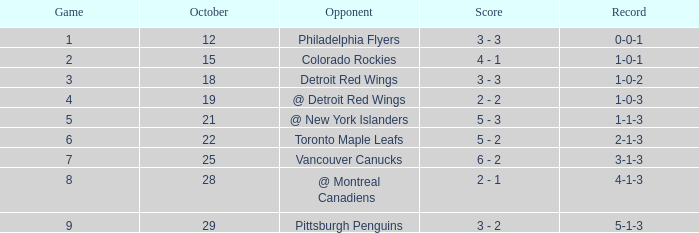Identify the most suitable game under 1 october. None. 